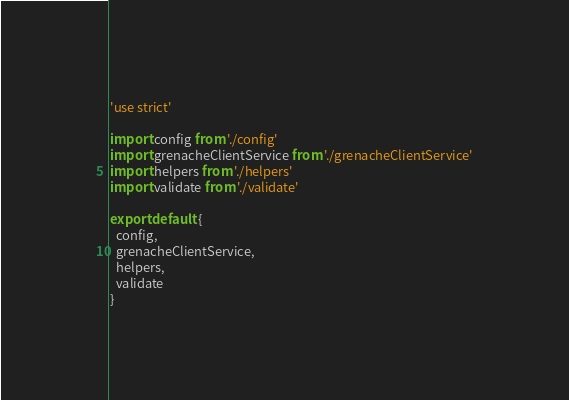<code> <loc_0><loc_0><loc_500><loc_500><_JavaScript_>'use strict'

import config from './config'
import grenacheClientService from './grenacheClientService'
import helpers from './helpers'
import validate from './validate'

export default {
  config,
  grenacheClientService,
  helpers,
  validate
}
</code> 